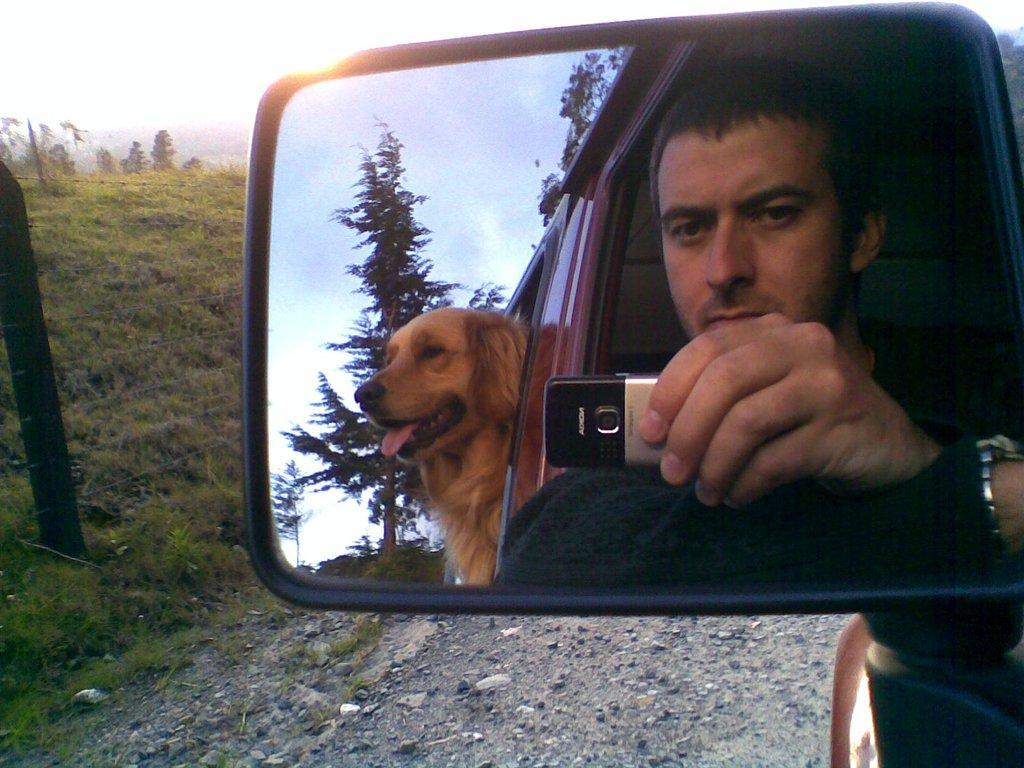Please provide a concise description of this image. In this picture I can see the car's mirror. In the mirror I can see the man who is holding a mobile phone. Behind him there is a dog. He is standing on the window. In the background I can see the sun, trees, plants, farm land and sky. In the mirror I can see the clouds. At the bottom I can see small stones. 